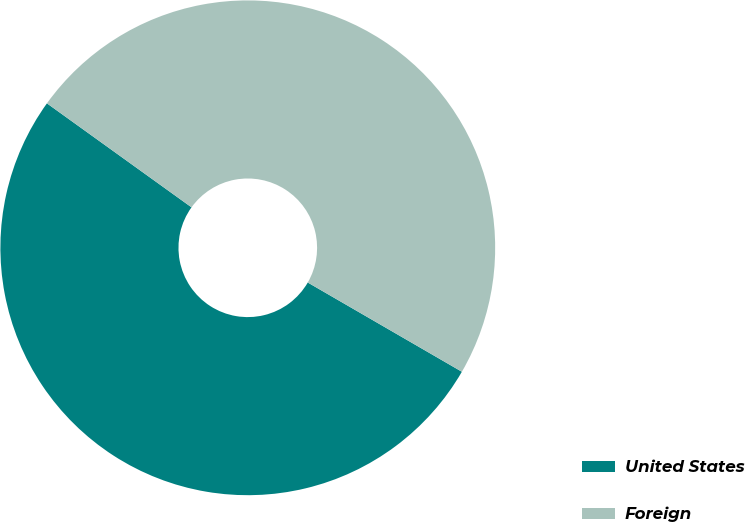Convert chart to OTSL. <chart><loc_0><loc_0><loc_500><loc_500><pie_chart><fcel>United States<fcel>Foreign<nl><fcel>51.57%<fcel>48.43%<nl></chart> 